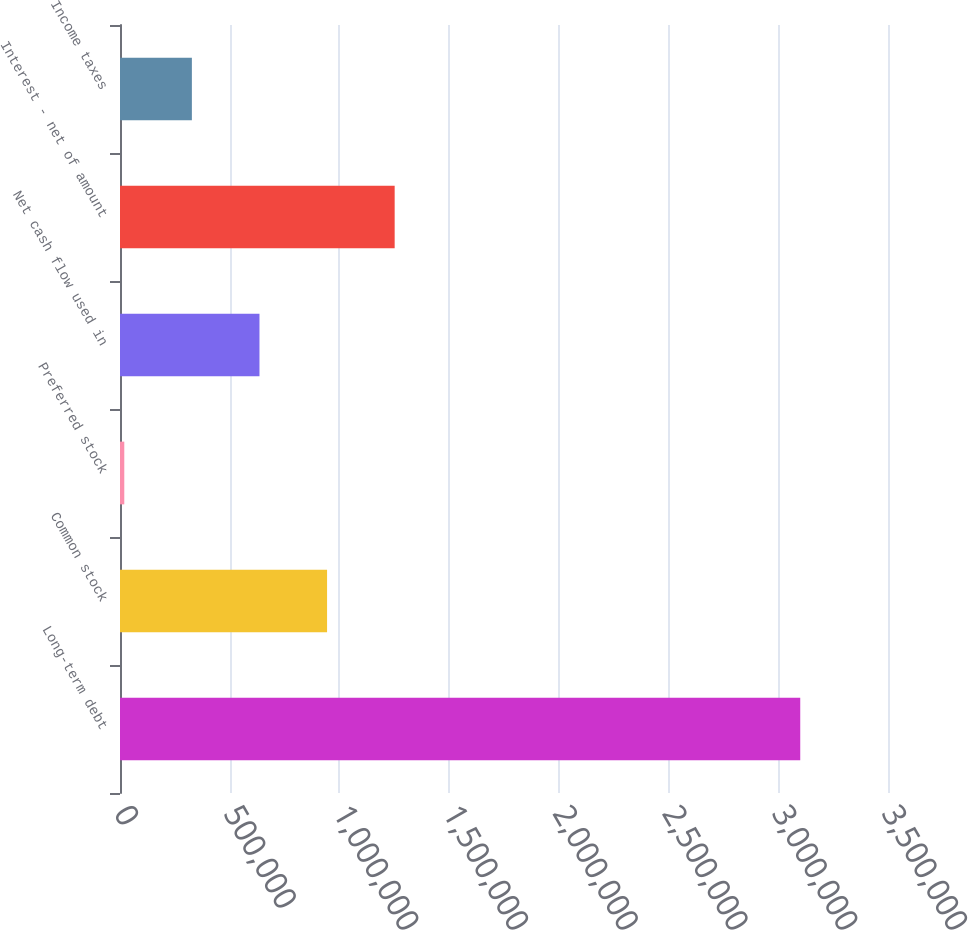<chart> <loc_0><loc_0><loc_500><loc_500><bar_chart><fcel>Long-term debt<fcel>Common stock<fcel>Preferred stock<fcel>Net cash flow used in<fcel>Interest - net of amount<fcel>Income taxes<nl><fcel>3.10007e+06<fcel>943678<fcel>19511<fcel>635623<fcel>1.25173e+06<fcel>327567<nl></chart> 